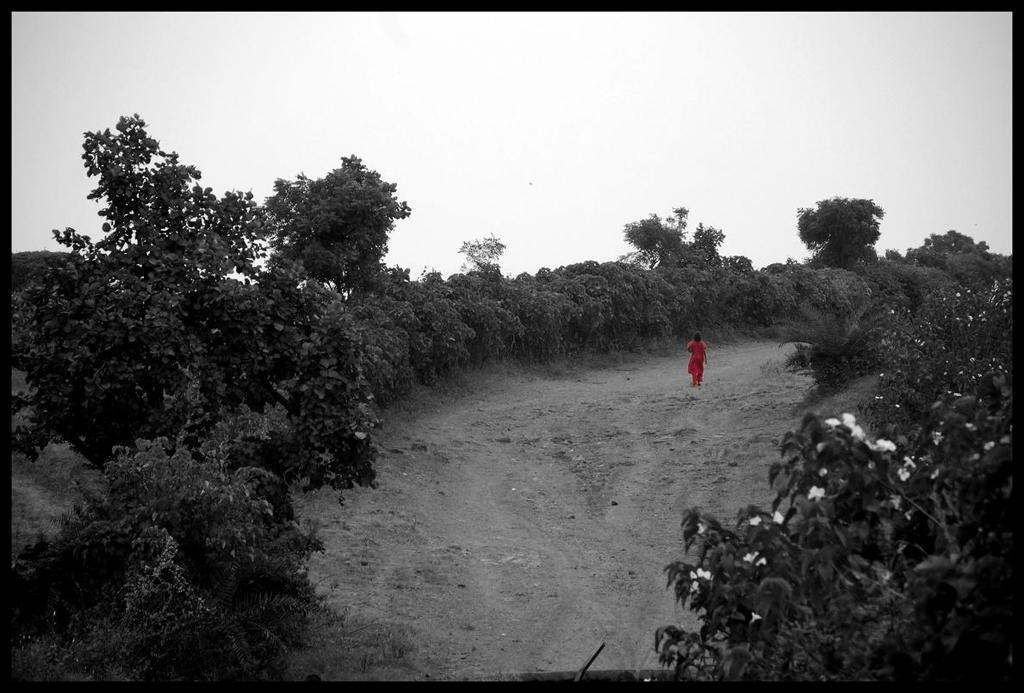Could you give a brief overview of what you see in this image? In this image I can see in the middle a person is walking, there are trees on either side of this image, at the top there is the sky. On the right side there are flowers. 